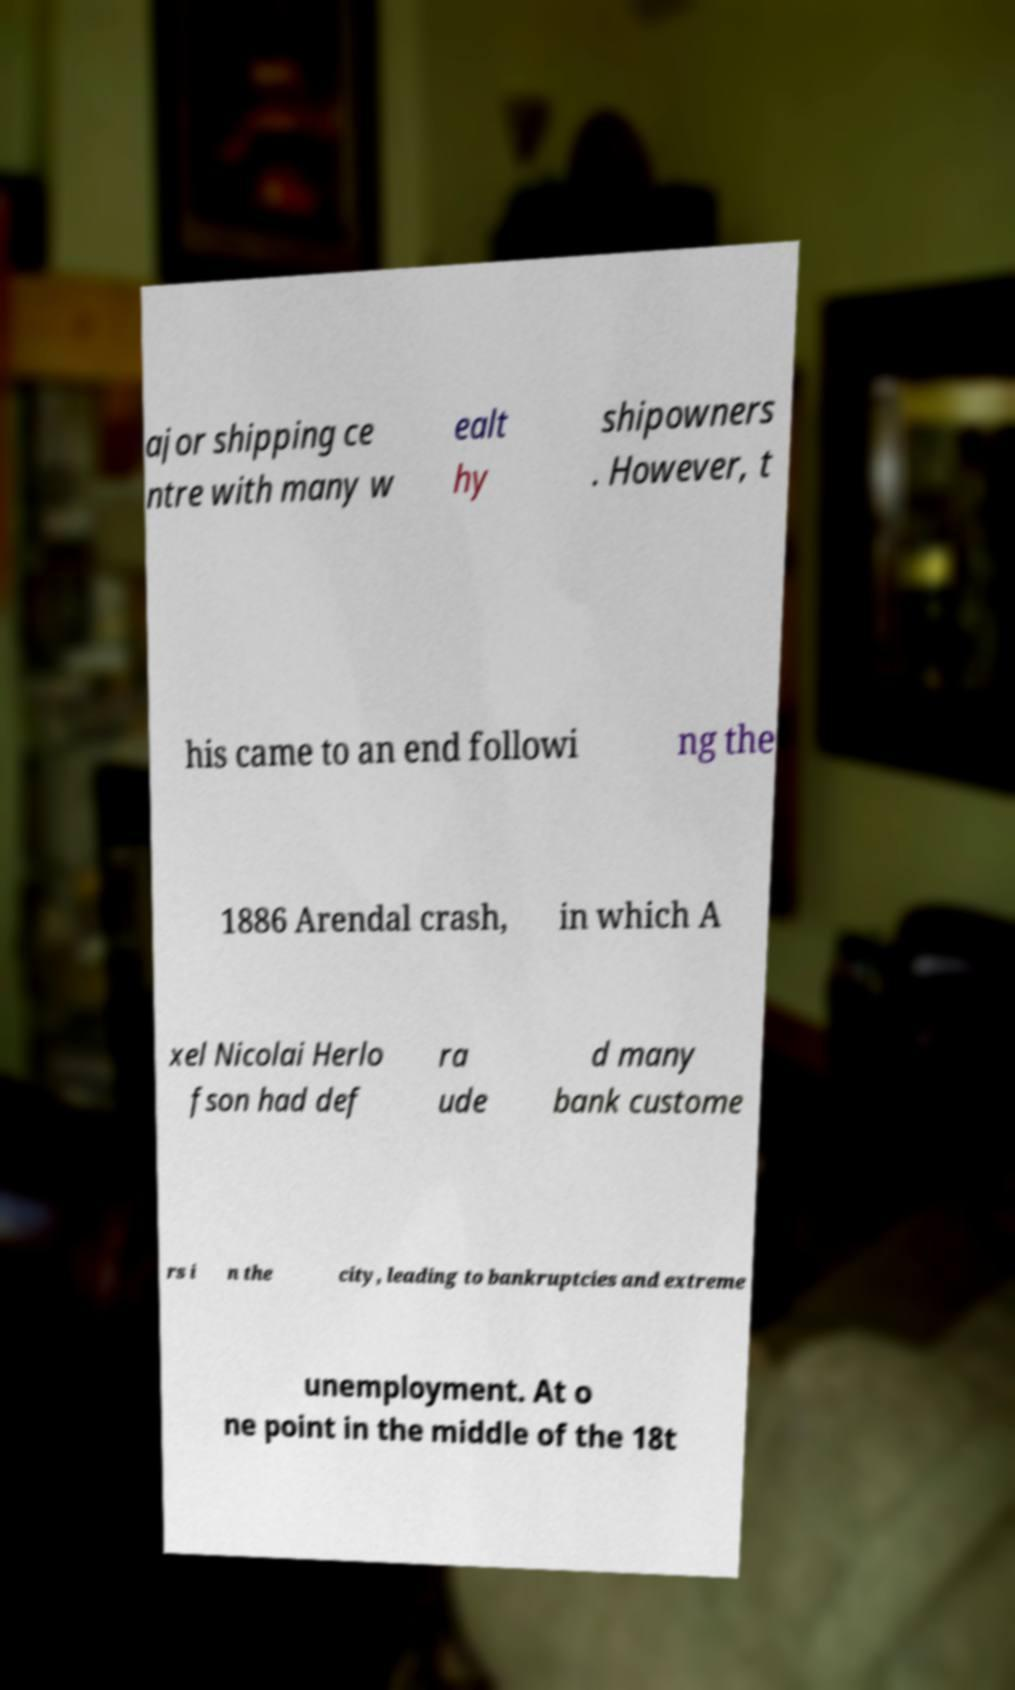Can you accurately transcribe the text from the provided image for me? ajor shipping ce ntre with many w ealt hy shipowners . However, t his came to an end followi ng the 1886 Arendal crash, in which A xel Nicolai Herlo fson had def ra ude d many bank custome rs i n the city, leading to bankruptcies and extreme unemployment. At o ne point in the middle of the 18t 